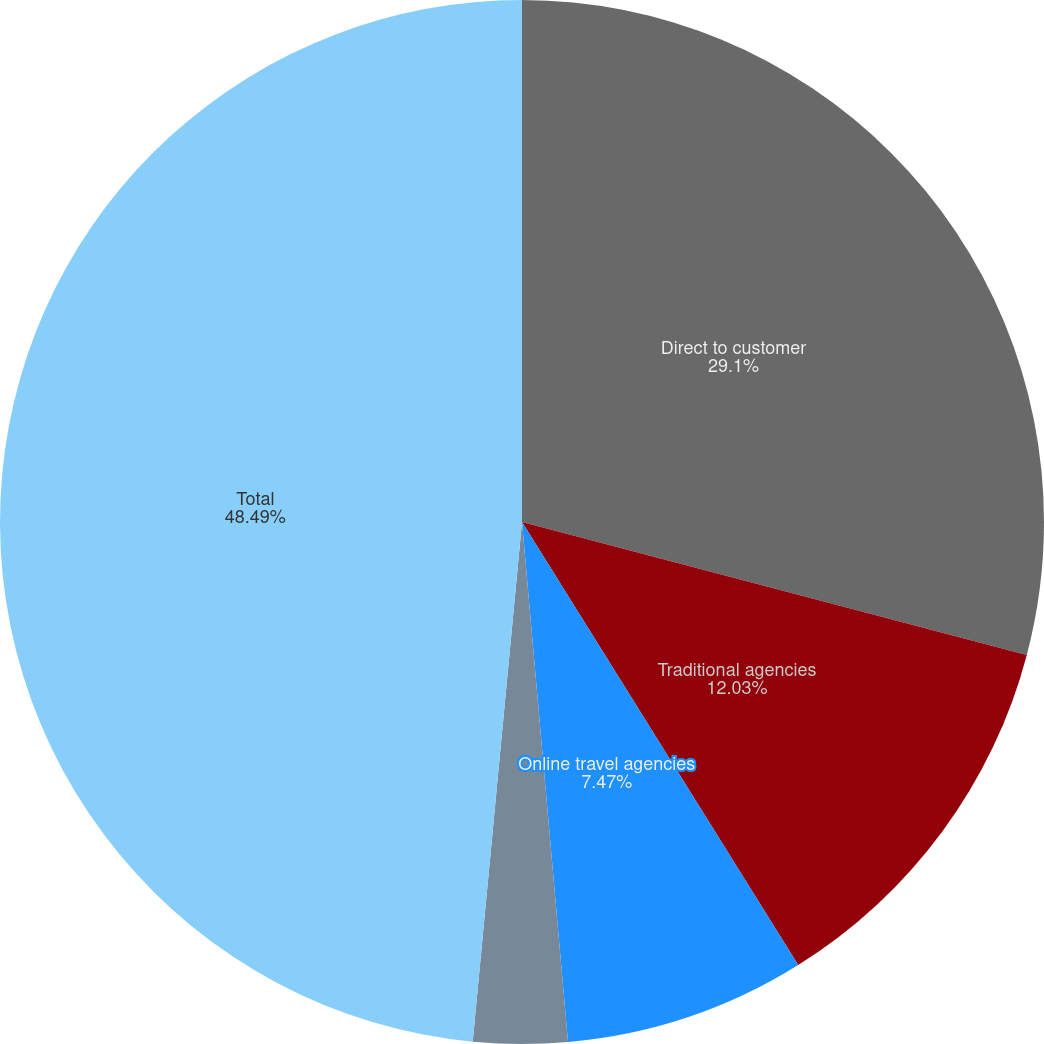<chart> <loc_0><loc_0><loc_500><loc_500><pie_chart><fcel>Direct to customer<fcel>Traditional agencies<fcel>Online travel agencies<fcel>Reservation call centers<fcel>Total<nl><fcel>29.1%<fcel>12.03%<fcel>7.47%<fcel>2.91%<fcel>48.5%<nl></chart> 